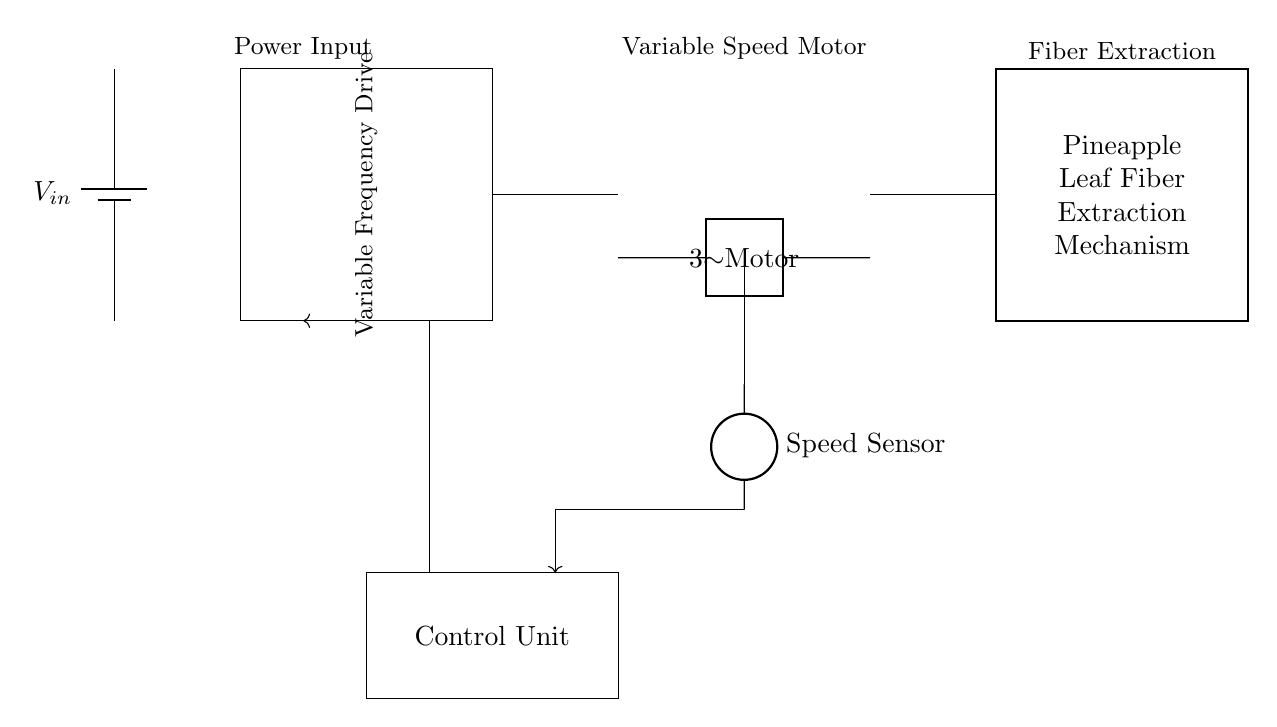What types of components are in this circuit? The circuit contains a power supply (battery), variable frequency drive, motor, fiber extraction mechanism, speed sensor, and control unit. Each of these components plays a specific role, contributing to the operation of the pineapple leaf fiber extraction machine.
Answer: battery, variable frequency drive, motor, fiber extraction mechanism, speed sensor, control unit What mechanism is implemented for fiber extraction? The mechanism depicted in the circuit for fiber extraction is a rectangular structure labeled "Pineapple Leaf Fiber Extraction Mechanism." This indicates that the circuit is specifically designed to facilitate the extraction of fibers from pineapple leaves.
Answer: Pineapple Leaf Fiber Extraction Mechanism Which component connects the speed sensor and control unit? The signal from the speed sensor is fed into the control unit through a feedback connection represented as an arrow. This connection is crucial for adjusting the motor's speed based on the extracted data from the speed sensor.
Answer: feedback connection How does the variable frequency drive influence the motor? The variable frequency drive regulates the speed of the motor by adjusting the frequency of the electricity supplied to it. This regulation allows for precise control over the extraction process based on the feedback received from the speed sensor, enabling more effective processing of the pineapple leaves.
Answer: regulates motor speed What is the function of the control unit in relation to the other components? The control unit processes the information from the speed sensor and adjusts the operation of the variable frequency drive, thereby controlling the motor. This control loop is essential for optimizing the extraction process by maintaining the desired motor speed based on real-time data.
Answer: processes speed data and adjusts motor operation What type of motor is indicated in this circuit? The circuit shows a two-port design labeled "Motor," indicating that it serves as an electric motor for driving the fiber extraction mechanism. The specific type isn't mentioned, but generally, it would be an electric motor suitable for variable speed applications.
Answer: Motor 